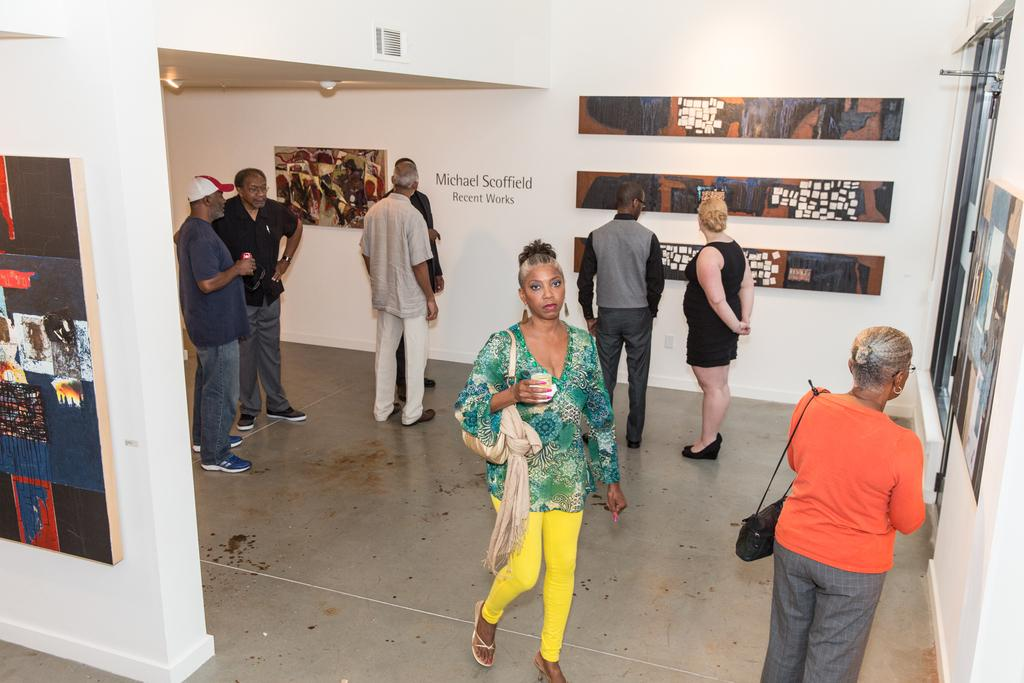What can be seen in the image? There are people standing in the image. What is the color of the wall in the image? There is a white color wall in the image. What is hanging on the wall? There are pictures on the wall. What type of reaction can be seen from the loaf in the image? There is no loaf present in the image, so it is not possible to determine any reaction. 